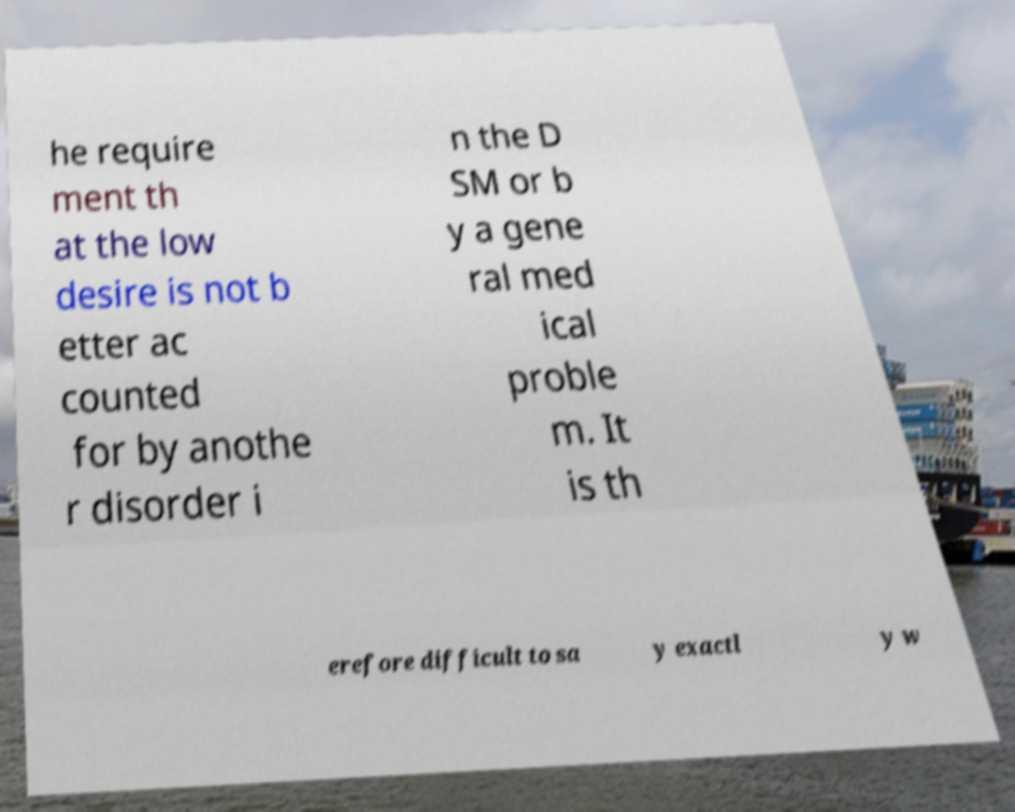Please read and relay the text visible in this image. What does it say? he require ment th at the low desire is not b etter ac counted for by anothe r disorder i n the D SM or b y a gene ral med ical proble m. It is th erefore difficult to sa y exactl y w 